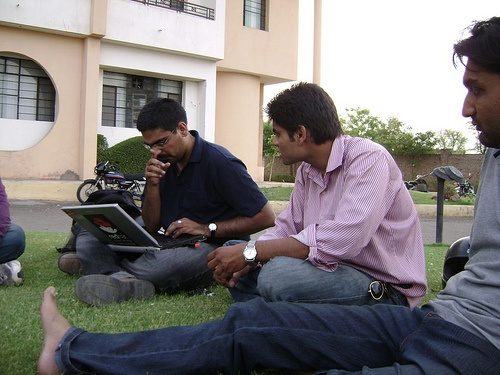Describe the objects in this image and their specific colors. I can see people in lightgray, black, navy, and gray tones, people in lightgray, darkgray, black, gray, and pink tones, people in lightgray, black, gray, and maroon tones, laptop in lightgray, black, gray, and darkgray tones, and people in lightgray, black, gray, navy, and darkgray tones in this image. 